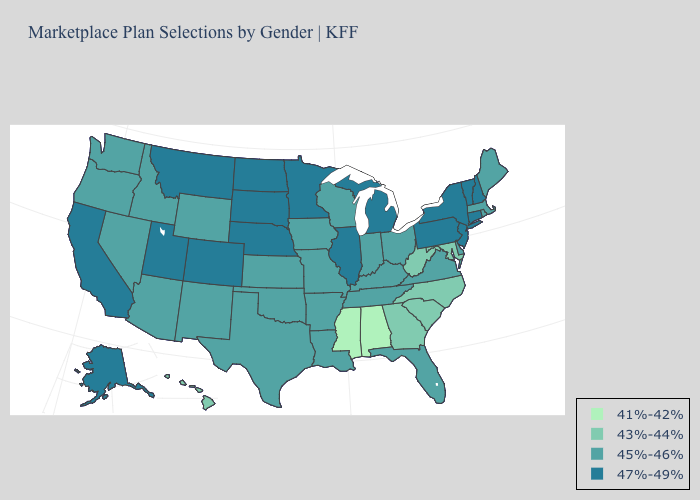Which states have the highest value in the USA?
Concise answer only. Alaska, California, Colorado, Connecticut, Illinois, Michigan, Minnesota, Montana, Nebraska, New Hampshire, New Jersey, New York, North Dakota, Pennsylvania, South Dakota, Utah, Vermont. What is the value of Florida?
Be succinct. 45%-46%. Does Massachusetts have a lower value than New Jersey?
Be succinct. Yes. Name the states that have a value in the range 45%-46%?
Give a very brief answer. Arizona, Arkansas, Delaware, Florida, Idaho, Indiana, Iowa, Kansas, Kentucky, Louisiana, Maine, Massachusetts, Missouri, Nevada, New Mexico, Ohio, Oklahoma, Oregon, Rhode Island, Tennessee, Texas, Virginia, Washington, Wisconsin, Wyoming. Does Mississippi have the lowest value in the USA?
Answer briefly. Yes. Does New York have the highest value in the USA?
Concise answer only. Yes. What is the value of Maryland?
Keep it brief. 43%-44%. What is the value of Hawaii?
Answer briefly. 43%-44%. What is the value of Connecticut?
Answer briefly. 47%-49%. Does Maryland have the highest value in the USA?
Concise answer only. No. What is the highest value in the Northeast ?
Quick response, please. 47%-49%. Name the states that have a value in the range 47%-49%?
Answer briefly. Alaska, California, Colorado, Connecticut, Illinois, Michigan, Minnesota, Montana, Nebraska, New Hampshire, New Jersey, New York, North Dakota, Pennsylvania, South Dakota, Utah, Vermont. What is the highest value in the Northeast ?
Short answer required. 47%-49%. What is the value of Massachusetts?
Quick response, please. 45%-46%. What is the highest value in the MidWest ?
Keep it brief. 47%-49%. 